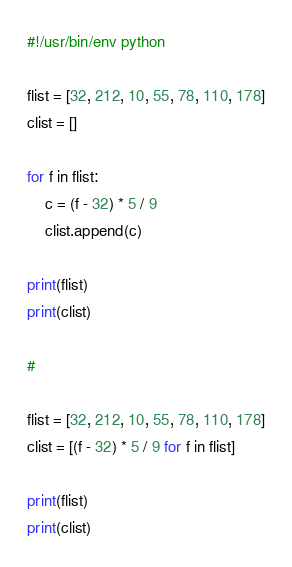<code> <loc_0><loc_0><loc_500><loc_500><_Python_>#!/usr/bin/env python

flist = [32, 212, 10, 55, 78, 110, 178]
clist = []

for f in flist:
    c = (f - 32) * 5 / 9
    clist.append(c)

print(flist)
print(clist)

#

flist = [32, 212, 10, 55, 78, 110, 178]
clist = [(f - 32) * 5 / 9 for f in flist]

print(flist)
print(clist)

</code> 